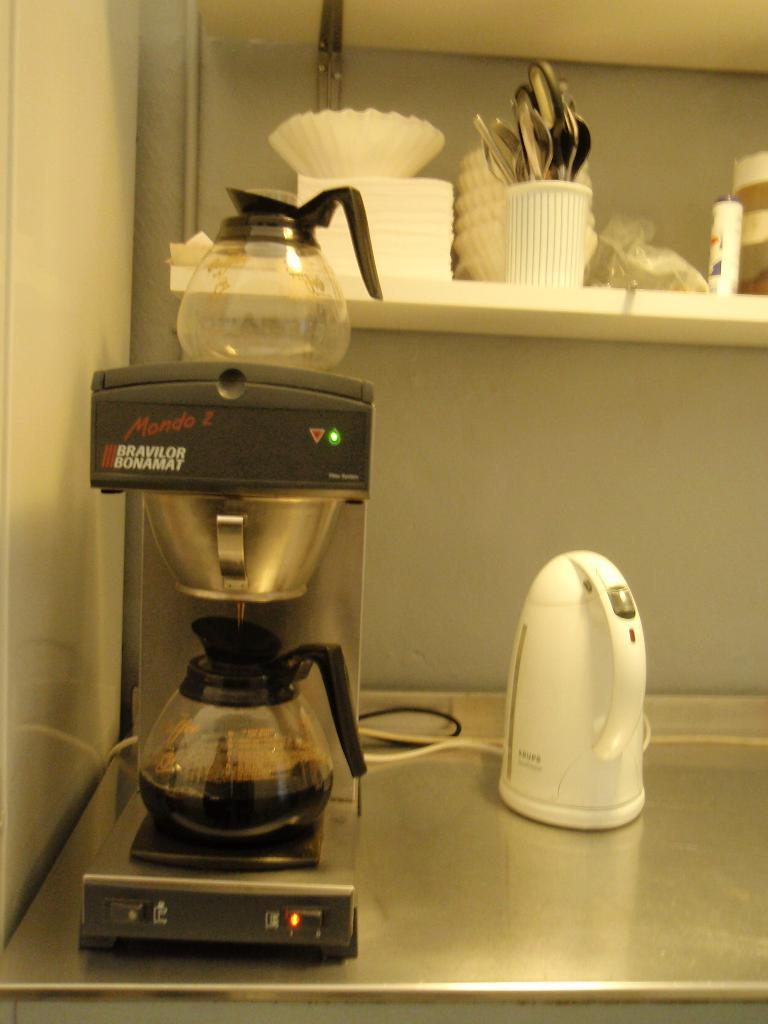<image>
Provide a brief description of the given image. A Mondo Z coffee pot is brewing coffee. 